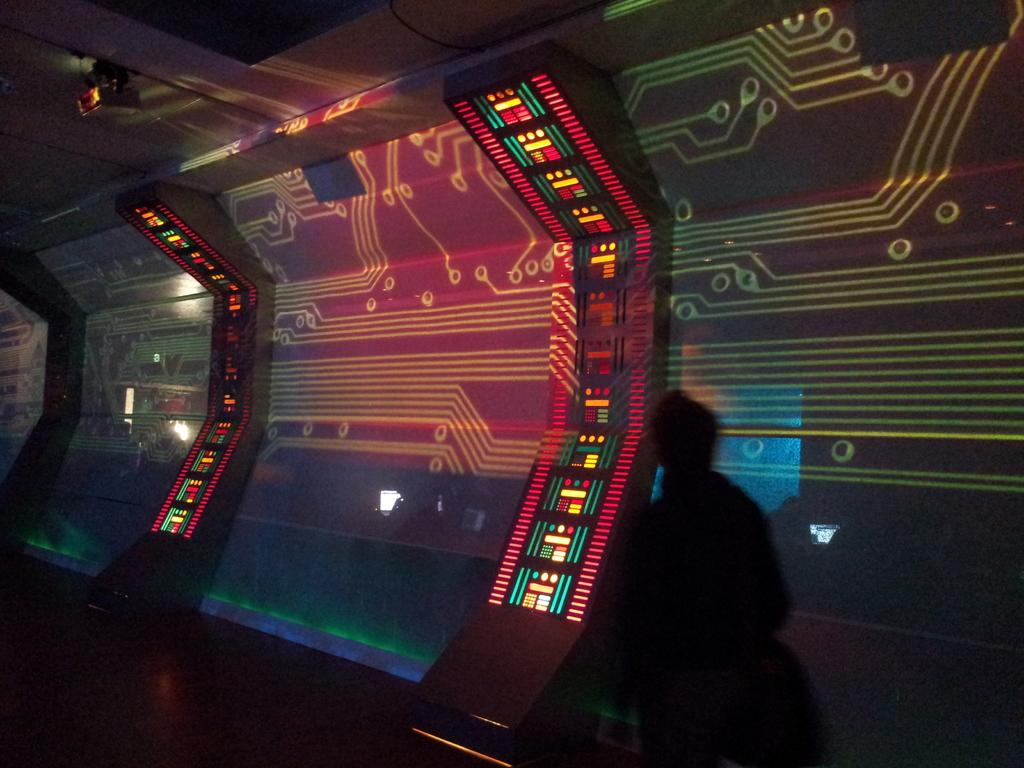What is the main subject in the foreground of the image? There is a person in the foreground of the image. What can be seen in the background of the image? There is a screen in the background of the image. What is visible at the bottom of the image? There is a floor visible at the bottom of the image. What is present at the top of the image? There is a light on the roof at the top of the image. How does the person in the image interact with the friction on the floor? There is no mention of friction in the image, and the person's interaction with the floor is not described. What type of salt can be seen on the screen in the image? There is no salt present on the screen in the image. 